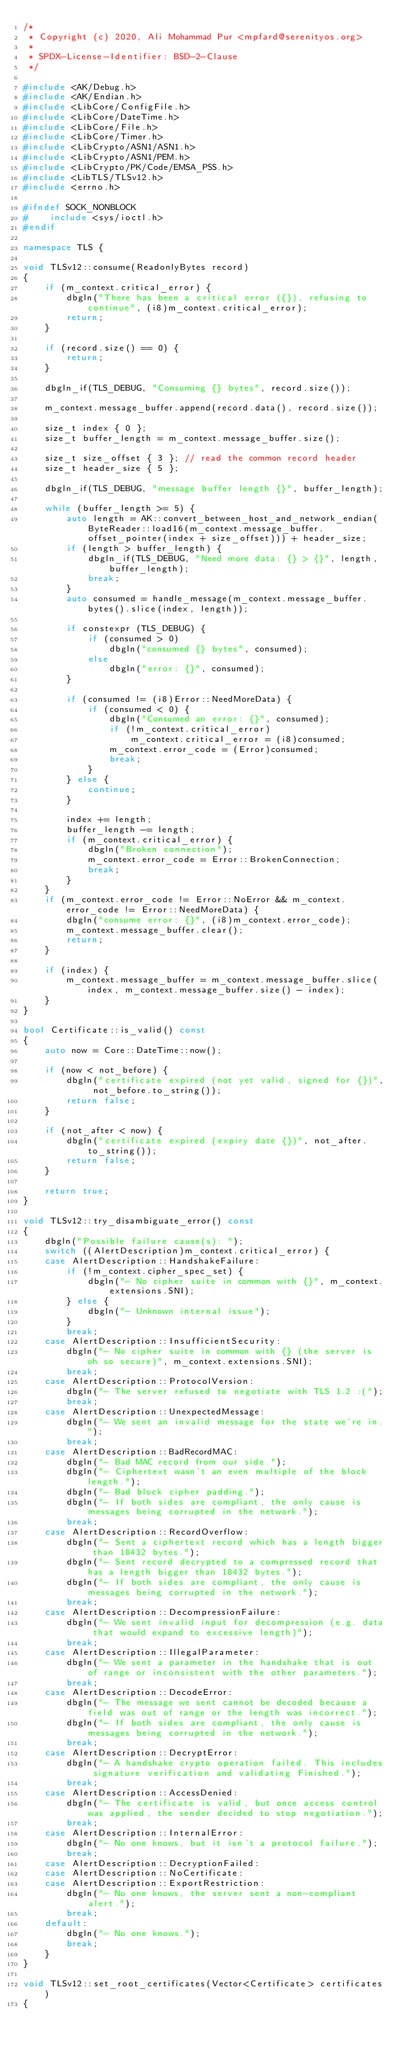Convert code to text. <code><loc_0><loc_0><loc_500><loc_500><_C++_>/*
 * Copyright (c) 2020, Ali Mohammad Pur <mpfard@serenityos.org>
 *
 * SPDX-License-Identifier: BSD-2-Clause
 */

#include <AK/Debug.h>
#include <AK/Endian.h>
#include <LibCore/ConfigFile.h>
#include <LibCore/DateTime.h>
#include <LibCore/File.h>
#include <LibCore/Timer.h>
#include <LibCrypto/ASN1/ASN1.h>
#include <LibCrypto/ASN1/PEM.h>
#include <LibCrypto/PK/Code/EMSA_PSS.h>
#include <LibTLS/TLSv12.h>
#include <errno.h>

#ifndef SOCK_NONBLOCK
#    include <sys/ioctl.h>
#endif

namespace TLS {

void TLSv12::consume(ReadonlyBytes record)
{
    if (m_context.critical_error) {
        dbgln("There has been a critical error ({}), refusing to continue", (i8)m_context.critical_error);
        return;
    }

    if (record.size() == 0) {
        return;
    }

    dbgln_if(TLS_DEBUG, "Consuming {} bytes", record.size());

    m_context.message_buffer.append(record.data(), record.size());

    size_t index { 0 };
    size_t buffer_length = m_context.message_buffer.size();

    size_t size_offset { 3 }; // read the common record header
    size_t header_size { 5 };

    dbgln_if(TLS_DEBUG, "message buffer length {}", buffer_length);

    while (buffer_length >= 5) {
        auto length = AK::convert_between_host_and_network_endian(ByteReader::load16(m_context.message_buffer.offset_pointer(index + size_offset))) + header_size;
        if (length > buffer_length) {
            dbgln_if(TLS_DEBUG, "Need more data: {} > {}", length, buffer_length);
            break;
        }
        auto consumed = handle_message(m_context.message_buffer.bytes().slice(index, length));

        if constexpr (TLS_DEBUG) {
            if (consumed > 0)
                dbgln("consumed {} bytes", consumed);
            else
                dbgln("error: {}", consumed);
        }

        if (consumed != (i8)Error::NeedMoreData) {
            if (consumed < 0) {
                dbgln("Consumed an error: {}", consumed);
                if (!m_context.critical_error)
                    m_context.critical_error = (i8)consumed;
                m_context.error_code = (Error)consumed;
                break;
            }
        } else {
            continue;
        }

        index += length;
        buffer_length -= length;
        if (m_context.critical_error) {
            dbgln("Broken connection");
            m_context.error_code = Error::BrokenConnection;
            break;
        }
    }
    if (m_context.error_code != Error::NoError && m_context.error_code != Error::NeedMoreData) {
        dbgln("consume error: {}", (i8)m_context.error_code);
        m_context.message_buffer.clear();
        return;
    }

    if (index) {
        m_context.message_buffer = m_context.message_buffer.slice(index, m_context.message_buffer.size() - index);
    }
}

bool Certificate::is_valid() const
{
    auto now = Core::DateTime::now();

    if (now < not_before) {
        dbgln("certificate expired (not yet valid, signed for {})", not_before.to_string());
        return false;
    }

    if (not_after < now) {
        dbgln("certificate expired (expiry date {})", not_after.to_string());
        return false;
    }

    return true;
}

void TLSv12::try_disambiguate_error() const
{
    dbgln("Possible failure cause(s): ");
    switch ((AlertDescription)m_context.critical_error) {
    case AlertDescription::HandshakeFailure:
        if (!m_context.cipher_spec_set) {
            dbgln("- No cipher suite in common with {}", m_context.extensions.SNI);
        } else {
            dbgln("- Unknown internal issue");
        }
        break;
    case AlertDescription::InsufficientSecurity:
        dbgln("- No cipher suite in common with {} (the server is oh so secure)", m_context.extensions.SNI);
        break;
    case AlertDescription::ProtocolVersion:
        dbgln("- The server refused to negotiate with TLS 1.2 :(");
        break;
    case AlertDescription::UnexpectedMessage:
        dbgln("- We sent an invalid message for the state we're in.");
        break;
    case AlertDescription::BadRecordMAC:
        dbgln("- Bad MAC record from our side.");
        dbgln("- Ciphertext wasn't an even multiple of the block length.");
        dbgln("- Bad block cipher padding.");
        dbgln("- If both sides are compliant, the only cause is messages being corrupted in the network.");
        break;
    case AlertDescription::RecordOverflow:
        dbgln("- Sent a ciphertext record which has a length bigger than 18432 bytes.");
        dbgln("- Sent record decrypted to a compressed record that has a length bigger than 18432 bytes.");
        dbgln("- If both sides are compliant, the only cause is messages being corrupted in the network.");
        break;
    case AlertDescription::DecompressionFailure:
        dbgln("- We sent invalid input for decompression (e.g. data that would expand to excessive length)");
        break;
    case AlertDescription::IllegalParameter:
        dbgln("- We sent a parameter in the handshake that is out of range or inconsistent with the other parameters.");
        break;
    case AlertDescription::DecodeError:
        dbgln("- The message we sent cannot be decoded because a field was out of range or the length was incorrect.");
        dbgln("- If both sides are compliant, the only cause is messages being corrupted in the network.");
        break;
    case AlertDescription::DecryptError:
        dbgln("- A handshake crypto operation failed. This includes signature verification and validating Finished.");
        break;
    case AlertDescription::AccessDenied:
        dbgln("- The certificate is valid, but once access control was applied, the sender decided to stop negotiation.");
        break;
    case AlertDescription::InternalError:
        dbgln("- No one knows, but it isn't a protocol failure.");
        break;
    case AlertDescription::DecryptionFailed:
    case AlertDescription::NoCertificate:
    case AlertDescription::ExportRestriction:
        dbgln("- No one knows, the server sent a non-compliant alert.");
        break;
    default:
        dbgln("- No one knows.");
        break;
    }
}

void TLSv12::set_root_certificates(Vector<Certificate> certificates)
{</code> 